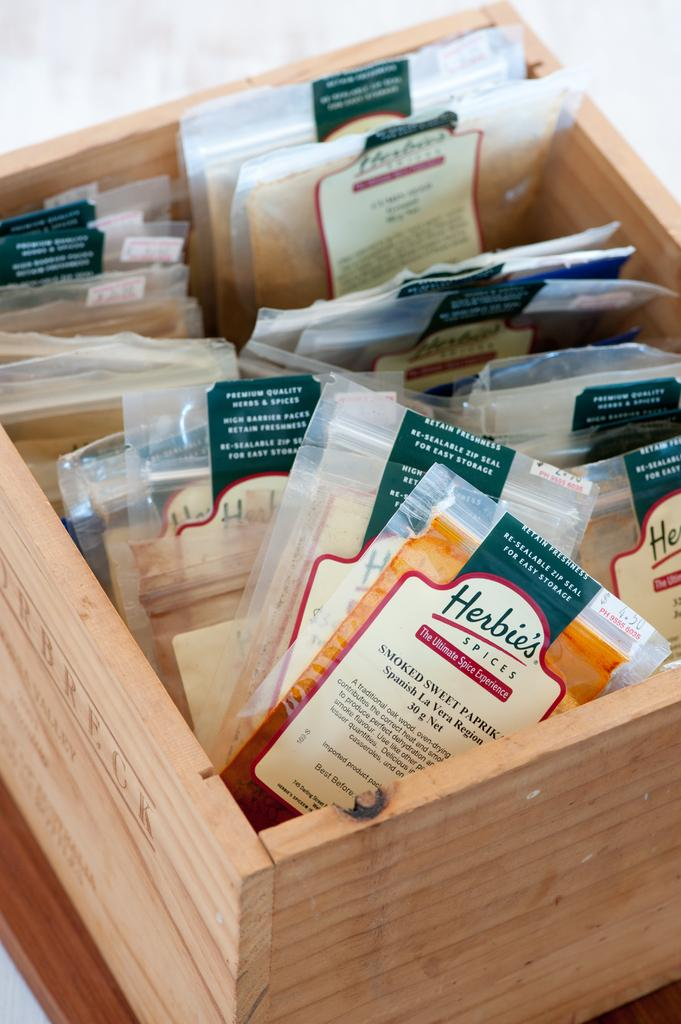<image>
Render a clear and concise summary of the photo. A box full of a selection of herbs and spices. 